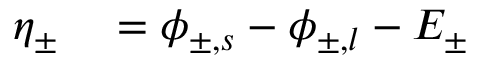Convert formula to latex. <formula><loc_0><loc_0><loc_500><loc_500>\begin{array} { r l } { \eta _ { \pm } } & = \phi _ { \pm , s } - \phi _ { \pm , l } - E _ { \pm } } \end{array}</formula> 